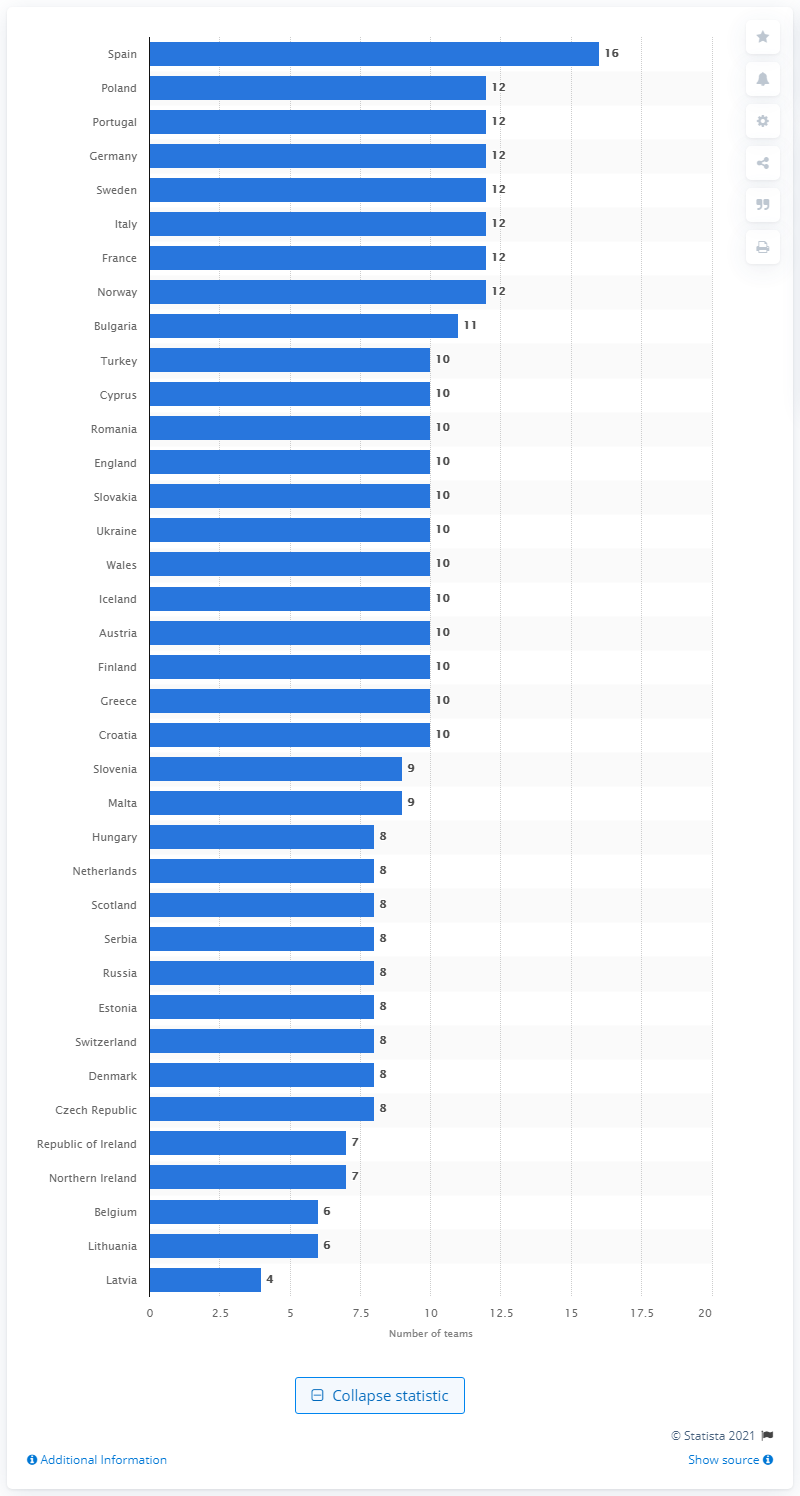Specify some key components in this picture. In 2017, there were 16 women's teams in Spain. 